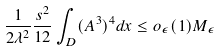Convert formula to latex. <formula><loc_0><loc_0><loc_500><loc_500>\frac { 1 } { 2 \lambda ^ { 2 } } \frac { s ^ { 2 } } { 1 2 } \int _ { D } ( A ^ { 3 } ) ^ { 4 } d x \leq o _ { \epsilon } ( 1 ) M _ { \epsilon }</formula> 